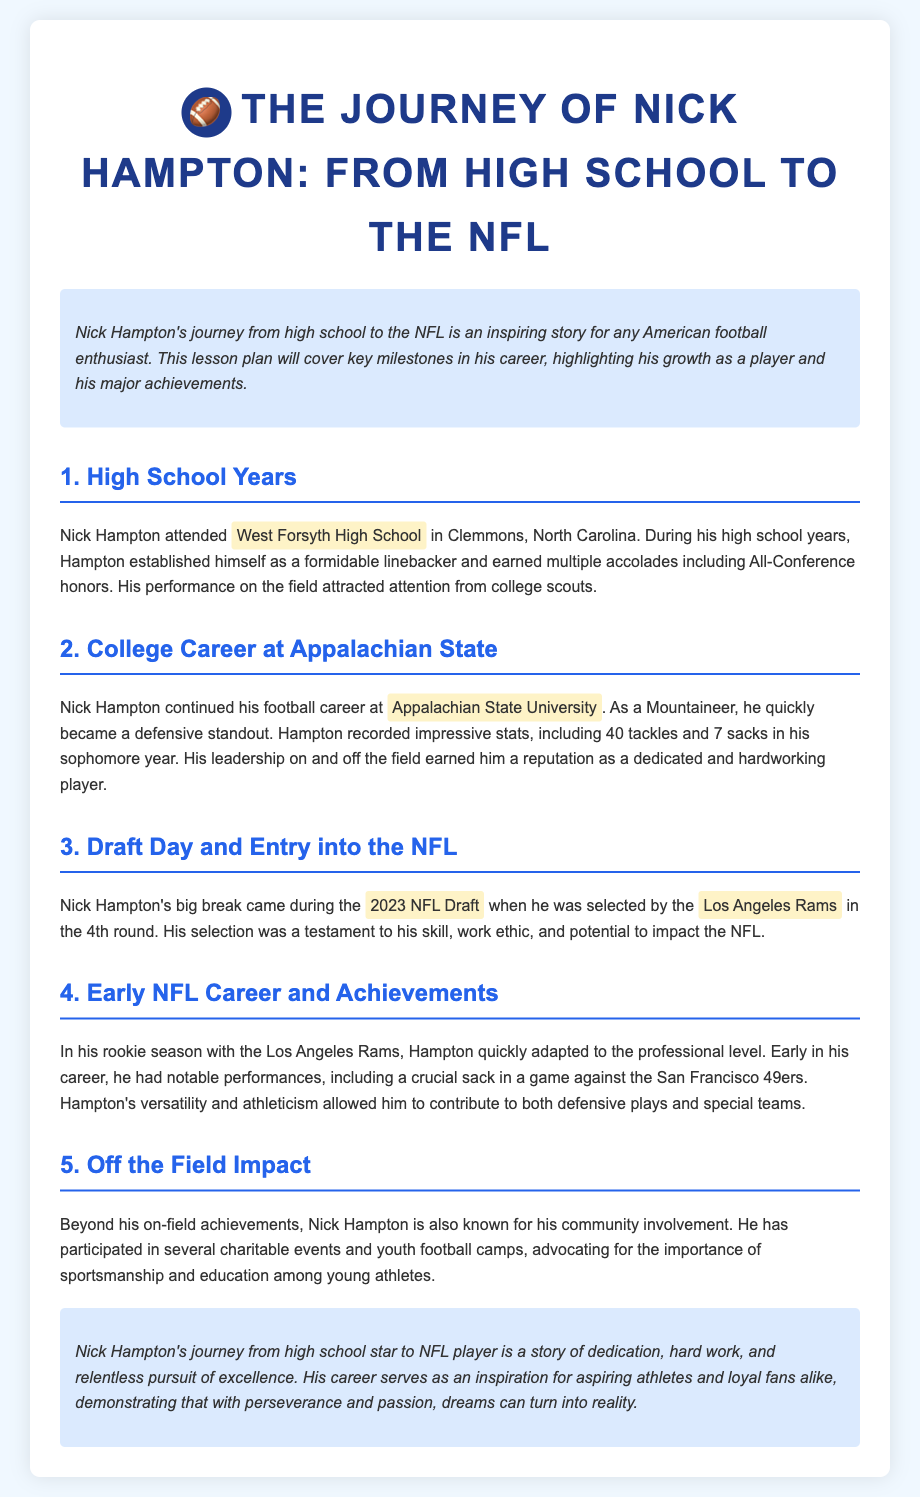What high school did Nick Hampton attend? The document states that Nick Hampton attended West Forsyth High School in Clemmons, North Carolina.
Answer: West Forsyth High School What college did Nick Hampton play for? According to the document, Nick Hampton continued his football career at Appalachian State University.
Answer: Appalachian State University In which round was Nick Hampton drafted? The document mentions that Nick Hampton was selected in the 4th round during the 2023 NFL Draft.
Answer: 4th round What notable statistic did Hampton achieve in his sophomore year? The document states that Hampton recorded 40 tackles and 7 sacks in his sophomore year.
Answer: 40 tackles and 7 sacks Which NFL team drafted Nick Hampton? The document specifies that he was selected by the Los Angeles Rams.
Answer: Los Angeles Rams What position did Nick Hampton play in high school? The document identifies Nick Hampton as a formidable linebacker during his high school years.
Answer: Linebacker What type of community involvement is Nick Hampton known for? The document indicates that he is known for participating in charitable events and youth football camps.
Answer: Charitable events and youth football camps What impact did Nick Hampton have in his rookie season? The document highlights notable performances including a crucial sack in a game against the San Francisco 49ers.
Answer: Crucial sack in game against the San Francisco 49ers 